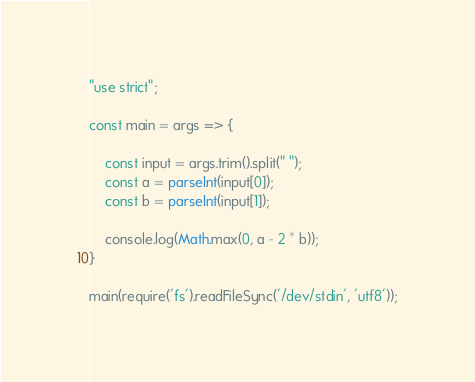Convert code to text. <code><loc_0><loc_0><loc_500><loc_500><_JavaScript_>"use strict";

const main = args => {

    const input = args.trim().split(" ");
    const a = parseInt(input[0]);
    const b = parseInt(input[1]);

    console.log(Math.max(0, a - 2 * b));
}

main(require('fs').readFileSync('/dev/stdin', 'utf8'));</code> 